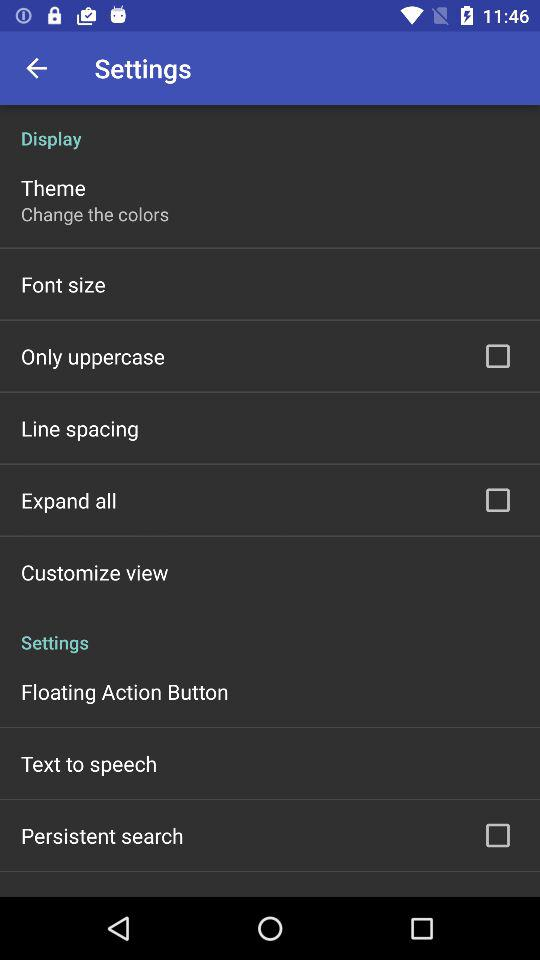Which font size is selected?
When the provided information is insufficient, respond with <no answer>. <no answer> 